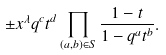<formula> <loc_0><loc_0><loc_500><loc_500>\pm x ^ { \lambda } q ^ { c } t ^ { d } \prod _ { ( a , b ) \in S } \frac { 1 - t } { 1 - q ^ { a } t ^ { b } } .</formula> 